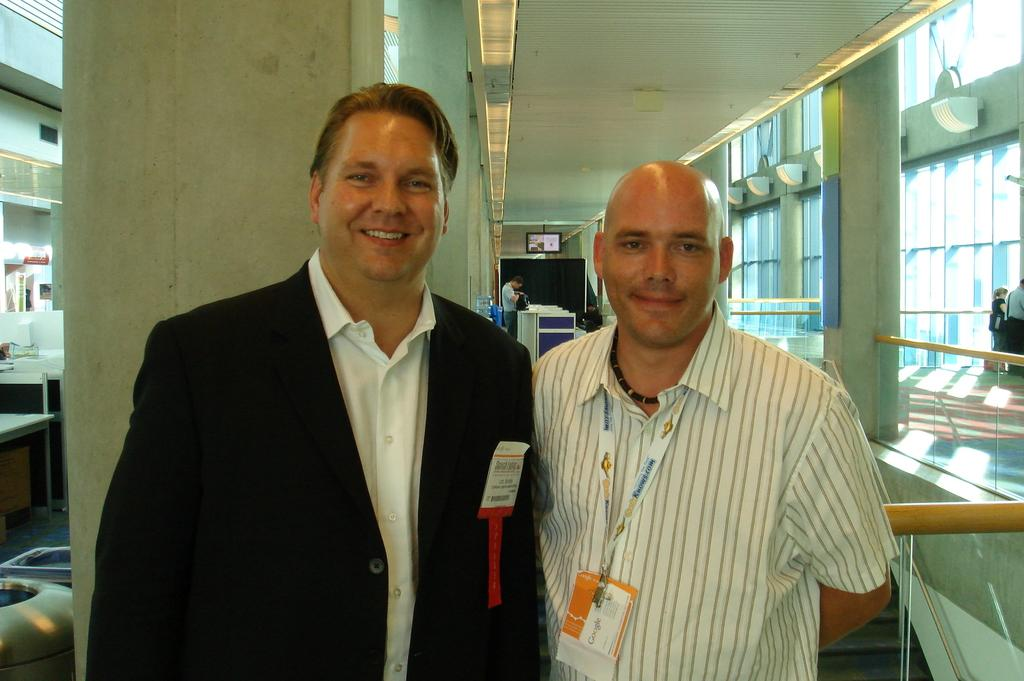How many people are standing in the image? There are 2 people standing in the image. What can be identified about the person on the right? The person on the right is wearing an id card. Can you describe the presence of another man in the image? There is another man at the back. What is one of the objects visible in the image? There is a screen in the image. Where are the other people standing in the image? Other people are standing on the right. What type of flower is growing on the bridge in the image? There is no bridge or flower present in the image. 